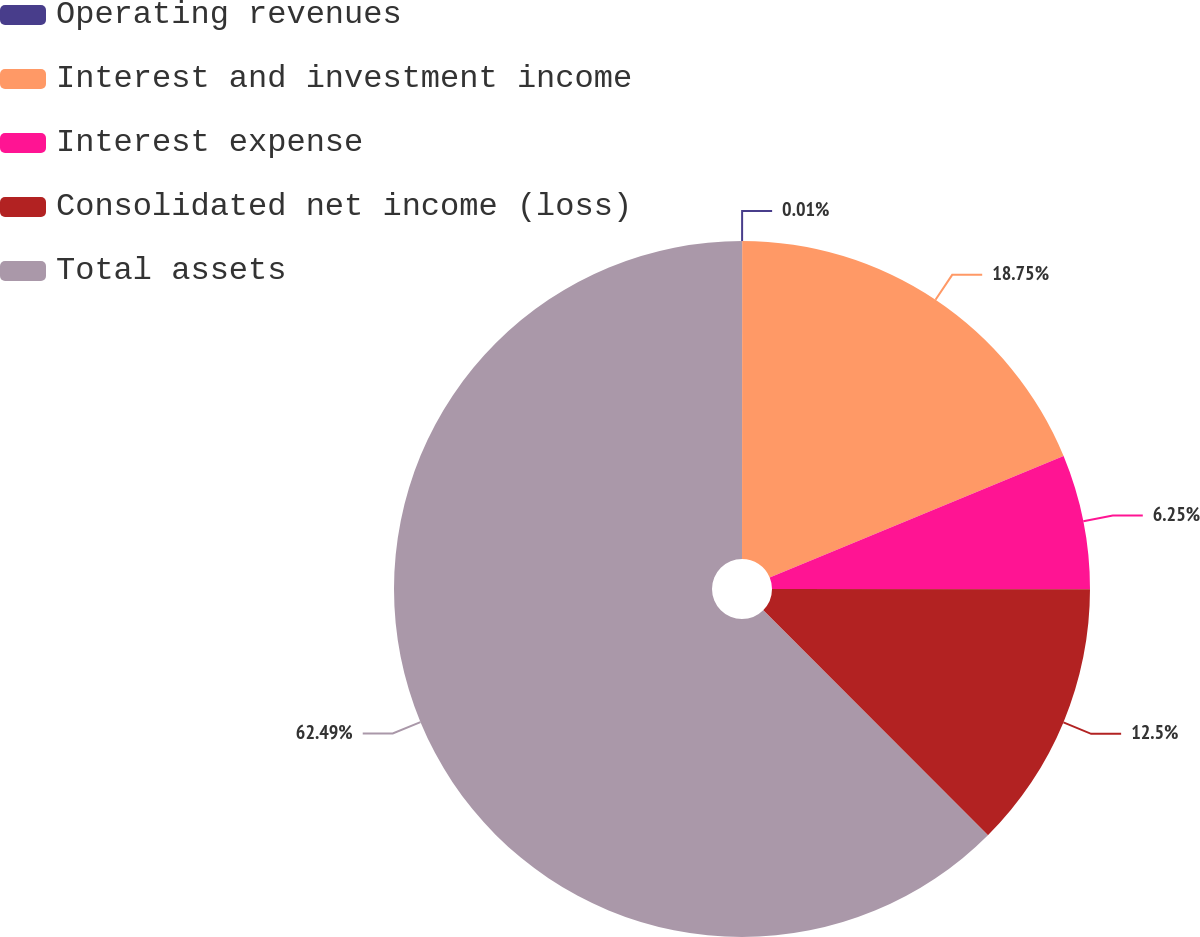Convert chart to OTSL. <chart><loc_0><loc_0><loc_500><loc_500><pie_chart><fcel>Operating revenues<fcel>Interest and investment income<fcel>Interest expense<fcel>Consolidated net income (loss)<fcel>Total assets<nl><fcel>0.01%<fcel>18.75%<fcel>6.25%<fcel>12.5%<fcel>62.49%<nl></chart> 